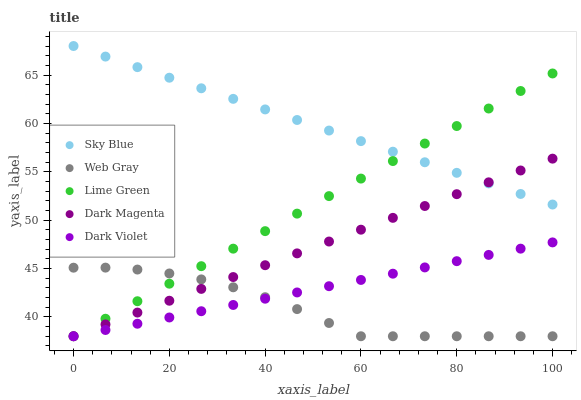Does Web Gray have the minimum area under the curve?
Answer yes or no. Yes. Does Sky Blue have the maximum area under the curve?
Answer yes or no. Yes. Does Lime Green have the minimum area under the curve?
Answer yes or no. No. Does Lime Green have the maximum area under the curve?
Answer yes or no. No. Is Dark Magenta the smoothest?
Answer yes or no. Yes. Is Web Gray the roughest?
Answer yes or no. Yes. Is Lime Green the smoothest?
Answer yes or no. No. Is Lime Green the roughest?
Answer yes or no. No. Does Web Gray have the lowest value?
Answer yes or no. Yes. Does Sky Blue have the highest value?
Answer yes or no. Yes. Does Lime Green have the highest value?
Answer yes or no. No. Is Dark Violet less than Sky Blue?
Answer yes or no. Yes. Is Sky Blue greater than Web Gray?
Answer yes or no. Yes. Does Lime Green intersect Web Gray?
Answer yes or no. Yes. Is Lime Green less than Web Gray?
Answer yes or no. No. Is Lime Green greater than Web Gray?
Answer yes or no. No. Does Dark Violet intersect Sky Blue?
Answer yes or no. No. 